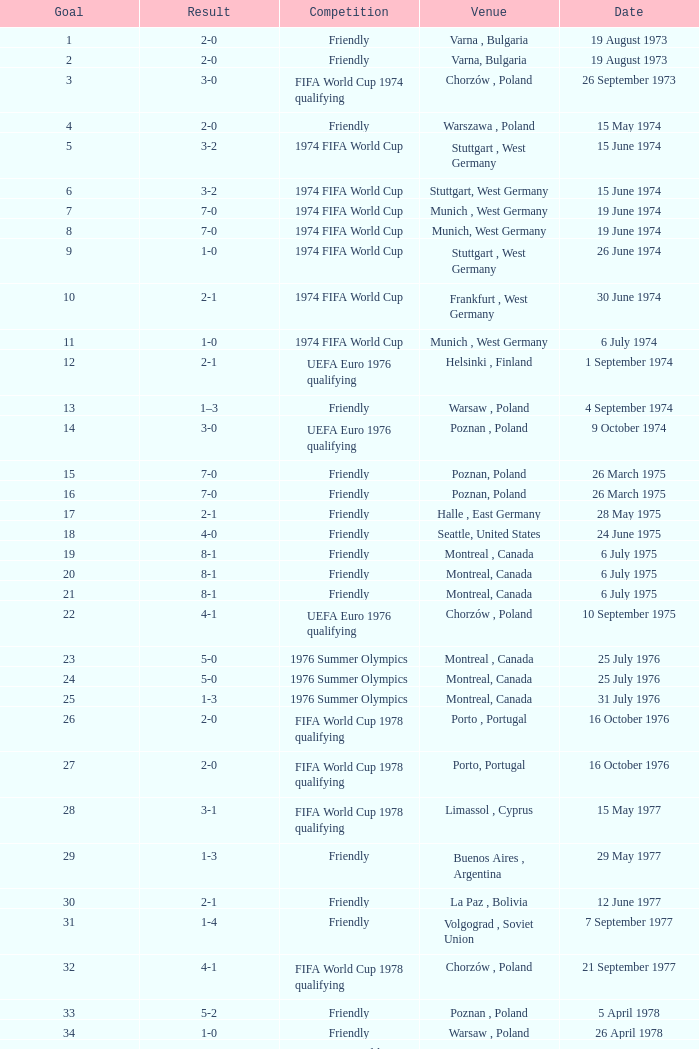What was the result of the game in Stuttgart, West Germany and a goal number of less than 9? 3-2, 3-2. 